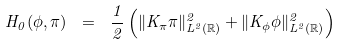<formula> <loc_0><loc_0><loc_500><loc_500>H _ { 0 } ( \phi , \pi ) \ = \ \frac { 1 } { 2 } \left ( \| K _ { \pi } \pi \| _ { L ^ { 2 } ( \mathbb { R } ) } ^ { 2 } + \| K _ { \phi } \phi \| _ { L ^ { 2 } ( \mathbb { R } ) } ^ { 2 } \right )</formula> 